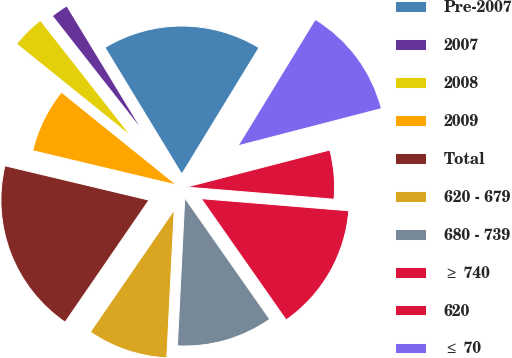Convert chart to OTSL. <chart><loc_0><loc_0><loc_500><loc_500><pie_chart><fcel>Pre-2007<fcel>2007<fcel>2008<fcel>2009<fcel>Total<fcel>620 - 679<fcel>680 - 739<fcel>≥ 740<fcel>620<fcel>≤ 70<nl><fcel>17.41%<fcel>1.9%<fcel>3.62%<fcel>7.07%<fcel>19.14%<fcel>8.79%<fcel>10.52%<fcel>13.97%<fcel>5.34%<fcel>12.24%<nl></chart> 